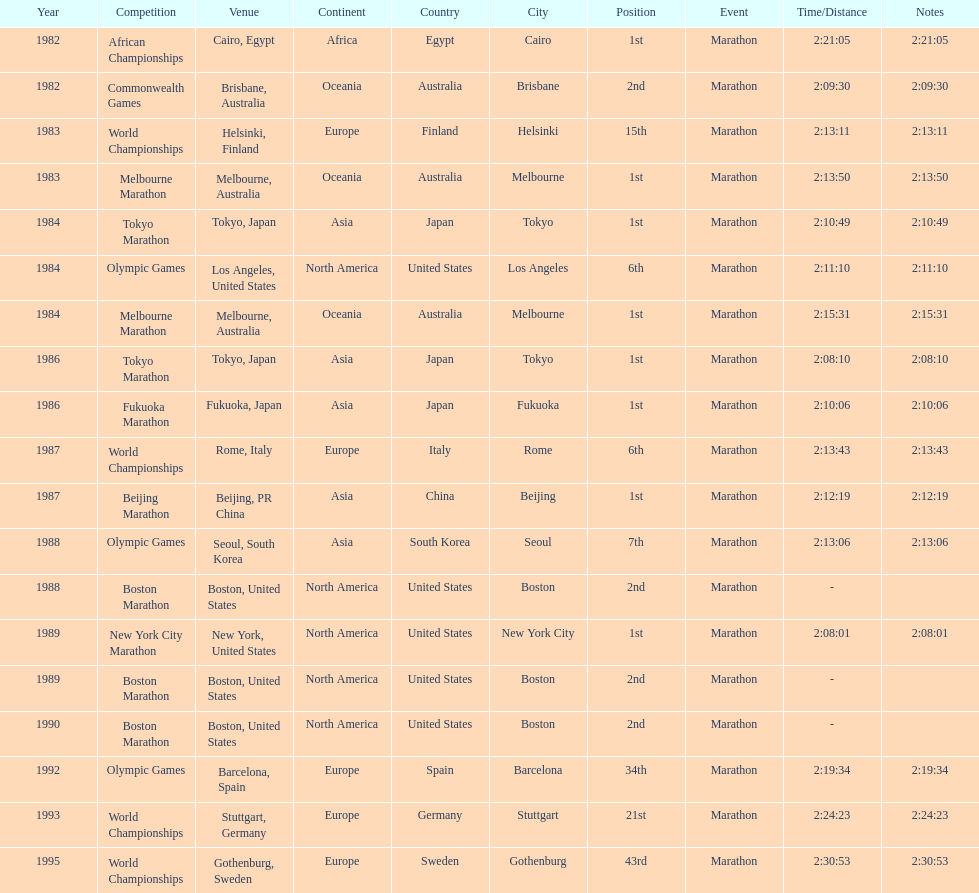Which was the only competition to occur in china? Beijing Marathon. 